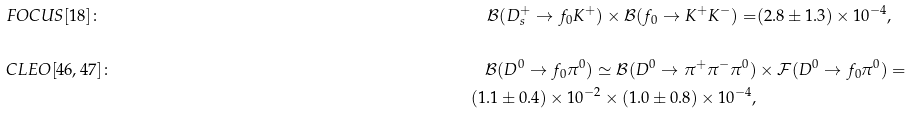<formula> <loc_0><loc_0><loc_500><loc_500>& F O C U S [ 1 8 ] \colon \, & \mathcal { B } ( D _ { s } ^ { + } \to f _ { 0 } K ^ { + } ) \times \mathcal { B } ( f _ { 0 } \to K ^ { + } K ^ { - } ) = & ( 2 . 8 \pm 1 . 3 ) \times 1 0 ^ { - 4 } , \\ \\ & C L E O [ 4 6 , 4 7 ] \colon \, & \mathcal { B } ( D ^ { 0 } \to f _ { 0 } \pi ^ { 0 } ) \simeq \mathcal { B } ( D ^ { 0 } \to \pi ^ { + } \pi ^ { - } \pi ^ { 0 } ) & \times \mathcal { F } ( D ^ { 0 } \to f _ { 0 } \pi ^ { 0 } ) = \\ & & ( 1 . 1 \pm 0 . 4 ) \times 1 0 ^ { - 2 } \times ( 1 . 0 \pm 0 . 8 ) \times 1 0 ^ { - 4 } ,</formula> 